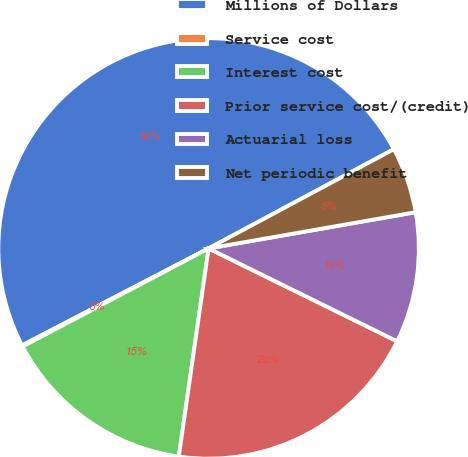Convert chart. <chart><loc_0><loc_0><loc_500><loc_500><pie_chart><fcel>Millions of Dollars<fcel>Service cost<fcel>Interest cost<fcel>Prior service cost/(credit)<fcel>Actuarial loss<fcel>Net periodic benefit<nl><fcel>49.8%<fcel>0.1%<fcel>15.01%<fcel>19.98%<fcel>10.04%<fcel>5.07%<nl></chart> 